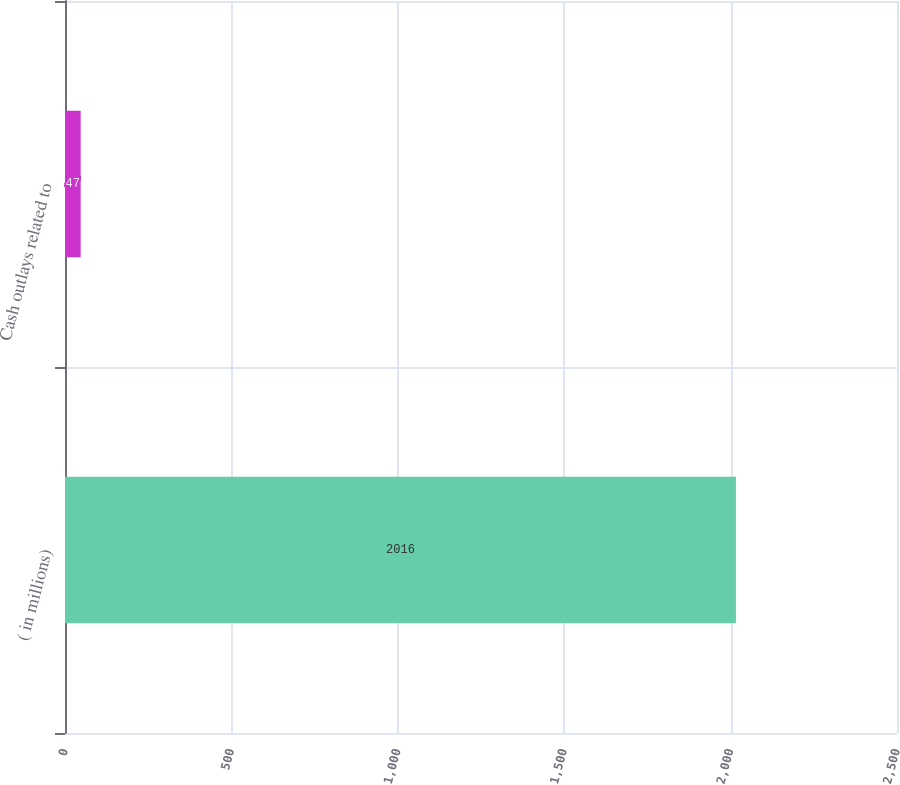Convert chart. <chart><loc_0><loc_0><loc_500><loc_500><bar_chart><fcel>( in millions)<fcel>Cash outlays related to<nl><fcel>2016<fcel>47<nl></chart> 